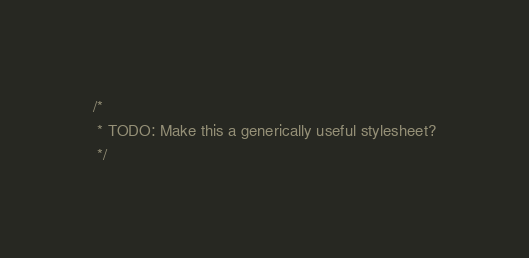Convert code to text. <code><loc_0><loc_0><loc_500><loc_500><_CSS_>/*
 * TODO: Make this a generically useful stylesheet?
 */
</code> 